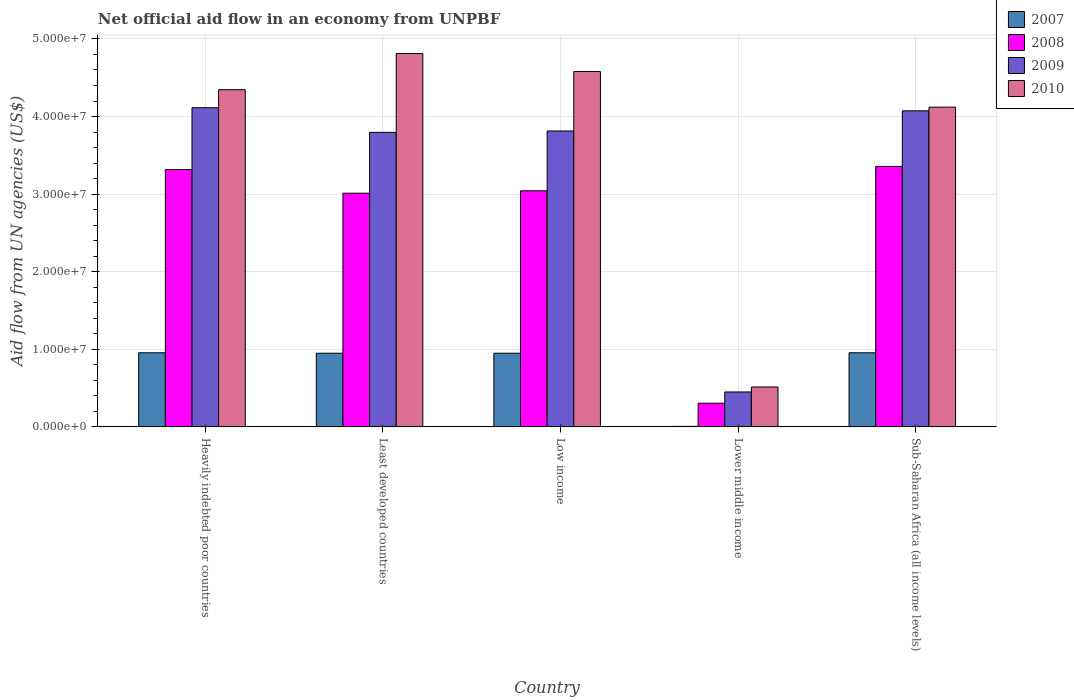How many different coloured bars are there?
Provide a short and direct response. 4. Are the number of bars per tick equal to the number of legend labels?
Your response must be concise. Yes. How many bars are there on the 4th tick from the left?
Your answer should be compact. 4. How many bars are there on the 1st tick from the right?
Your response must be concise. 4. What is the label of the 1st group of bars from the left?
Make the answer very short. Heavily indebted poor countries. In how many cases, is the number of bars for a given country not equal to the number of legend labels?
Keep it short and to the point. 0. What is the net official aid flow in 2007 in Low income?
Provide a succinct answer. 9.49e+06. Across all countries, what is the maximum net official aid flow in 2010?
Your response must be concise. 4.81e+07. Across all countries, what is the minimum net official aid flow in 2010?
Your response must be concise. 5.14e+06. In which country was the net official aid flow in 2010 maximum?
Your response must be concise. Least developed countries. In which country was the net official aid flow in 2010 minimum?
Your response must be concise. Lower middle income. What is the total net official aid flow in 2007 in the graph?
Provide a succinct answer. 3.81e+07. What is the difference between the net official aid flow in 2008 in Heavily indebted poor countries and the net official aid flow in 2009 in Low income?
Your answer should be compact. -4.97e+06. What is the average net official aid flow in 2010 per country?
Make the answer very short. 3.67e+07. What is the difference between the net official aid flow of/in 2008 and net official aid flow of/in 2007 in Least developed countries?
Offer a terse response. 2.06e+07. What is the ratio of the net official aid flow in 2010 in Heavily indebted poor countries to that in Least developed countries?
Ensure brevity in your answer.  0.9. Is the net official aid flow in 2009 in Least developed countries less than that in Low income?
Your answer should be very brief. Yes. What is the difference between the highest and the second highest net official aid flow in 2009?
Ensure brevity in your answer.  3.00e+06. What is the difference between the highest and the lowest net official aid flow in 2010?
Keep it short and to the point. 4.30e+07. Is the sum of the net official aid flow in 2007 in Heavily indebted poor countries and Lower middle income greater than the maximum net official aid flow in 2010 across all countries?
Provide a short and direct response. No. What does the 1st bar from the left in Low income represents?
Your answer should be compact. 2007. What does the 4th bar from the right in Least developed countries represents?
Offer a very short reply. 2007. Is it the case that in every country, the sum of the net official aid flow in 2007 and net official aid flow in 2009 is greater than the net official aid flow in 2010?
Your answer should be very brief. No. What is the difference between two consecutive major ticks on the Y-axis?
Make the answer very short. 1.00e+07. Are the values on the major ticks of Y-axis written in scientific E-notation?
Offer a terse response. Yes. Does the graph contain any zero values?
Provide a short and direct response. No. Does the graph contain grids?
Your answer should be compact. Yes. Where does the legend appear in the graph?
Your answer should be very brief. Top right. How many legend labels are there?
Offer a terse response. 4. What is the title of the graph?
Provide a succinct answer. Net official aid flow in an economy from UNPBF. What is the label or title of the Y-axis?
Your response must be concise. Aid flow from UN agencies (US$). What is the Aid flow from UN agencies (US$) in 2007 in Heavily indebted poor countries?
Provide a short and direct response. 9.55e+06. What is the Aid flow from UN agencies (US$) of 2008 in Heavily indebted poor countries?
Make the answer very short. 3.32e+07. What is the Aid flow from UN agencies (US$) of 2009 in Heavily indebted poor countries?
Keep it short and to the point. 4.11e+07. What is the Aid flow from UN agencies (US$) of 2010 in Heavily indebted poor countries?
Your response must be concise. 4.35e+07. What is the Aid flow from UN agencies (US$) of 2007 in Least developed countries?
Make the answer very short. 9.49e+06. What is the Aid flow from UN agencies (US$) in 2008 in Least developed countries?
Make the answer very short. 3.01e+07. What is the Aid flow from UN agencies (US$) in 2009 in Least developed countries?
Your answer should be very brief. 3.80e+07. What is the Aid flow from UN agencies (US$) in 2010 in Least developed countries?
Your response must be concise. 4.81e+07. What is the Aid flow from UN agencies (US$) in 2007 in Low income?
Keep it short and to the point. 9.49e+06. What is the Aid flow from UN agencies (US$) of 2008 in Low income?
Make the answer very short. 3.04e+07. What is the Aid flow from UN agencies (US$) of 2009 in Low income?
Offer a very short reply. 3.81e+07. What is the Aid flow from UN agencies (US$) of 2010 in Low income?
Keep it short and to the point. 4.58e+07. What is the Aid flow from UN agencies (US$) of 2008 in Lower middle income?
Your response must be concise. 3.05e+06. What is the Aid flow from UN agencies (US$) in 2009 in Lower middle income?
Give a very brief answer. 4.50e+06. What is the Aid flow from UN agencies (US$) of 2010 in Lower middle income?
Your response must be concise. 5.14e+06. What is the Aid flow from UN agencies (US$) in 2007 in Sub-Saharan Africa (all income levels)?
Make the answer very short. 9.55e+06. What is the Aid flow from UN agencies (US$) in 2008 in Sub-Saharan Africa (all income levels)?
Offer a terse response. 3.36e+07. What is the Aid flow from UN agencies (US$) of 2009 in Sub-Saharan Africa (all income levels)?
Your answer should be compact. 4.07e+07. What is the Aid flow from UN agencies (US$) in 2010 in Sub-Saharan Africa (all income levels)?
Provide a short and direct response. 4.12e+07. Across all countries, what is the maximum Aid flow from UN agencies (US$) of 2007?
Ensure brevity in your answer.  9.55e+06. Across all countries, what is the maximum Aid flow from UN agencies (US$) in 2008?
Give a very brief answer. 3.36e+07. Across all countries, what is the maximum Aid flow from UN agencies (US$) in 2009?
Your response must be concise. 4.11e+07. Across all countries, what is the maximum Aid flow from UN agencies (US$) in 2010?
Provide a succinct answer. 4.81e+07. Across all countries, what is the minimum Aid flow from UN agencies (US$) in 2007?
Keep it short and to the point. 6.00e+04. Across all countries, what is the minimum Aid flow from UN agencies (US$) of 2008?
Offer a very short reply. 3.05e+06. Across all countries, what is the minimum Aid flow from UN agencies (US$) in 2009?
Make the answer very short. 4.50e+06. Across all countries, what is the minimum Aid flow from UN agencies (US$) in 2010?
Give a very brief answer. 5.14e+06. What is the total Aid flow from UN agencies (US$) in 2007 in the graph?
Keep it short and to the point. 3.81e+07. What is the total Aid flow from UN agencies (US$) in 2008 in the graph?
Keep it short and to the point. 1.30e+08. What is the total Aid flow from UN agencies (US$) in 2009 in the graph?
Your answer should be very brief. 1.62e+08. What is the total Aid flow from UN agencies (US$) of 2010 in the graph?
Offer a very short reply. 1.84e+08. What is the difference between the Aid flow from UN agencies (US$) of 2007 in Heavily indebted poor countries and that in Least developed countries?
Provide a succinct answer. 6.00e+04. What is the difference between the Aid flow from UN agencies (US$) in 2008 in Heavily indebted poor countries and that in Least developed countries?
Offer a terse response. 3.05e+06. What is the difference between the Aid flow from UN agencies (US$) in 2009 in Heavily indebted poor countries and that in Least developed countries?
Provide a succinct answer. 3.18e+06. What is the difference between the Aid flow from UN agencies (US$) in 2010 in Heavily indebted poor countries and that in Least developed countries?
Make the answer very short. -4.66e+06. What is the difference between the Aid flow from UN agencies (US$) of 2008 in Heavily indebted poor countries and that in Low income?
Your answer should be compact. 2.74e+06. What is the difference between the Aid flow from UN agencies (US$) in 2010 in Heavily indebted poor countries and that in Low income?
Offer a terse response. -2.34e+06. What is the difference between the Aid flow from UN agencies (US$) in 2007 in Heavily indebted poor countries and that in Lower middle income?
Give a very brief answer. 9.49e+06. What is the difference between the Aid flow from UN agencies (US$) in 2008 in Heavily indebted poor countries and that in Lower middle income?
Your answer should be compact. 3.01e+07. What is the difference between the Aid flow from UN agencies (US$) of 2009 in Heavily indebted poor countries and that in Lower middle income?
Make the answer very short. 3.66e+07. What is the difference between the Aid flow from UN agencies (US$) of 2010 in Heavily indebted poor countries and that in Lower middle income?
Your response must be concise. 3.83e+07. What is the difference between the Aid flow from UN agencies (US$) in 2007 in Heavily indebted poor countries and that in Sub-Saharan Africa (all income levels)?
Your answer should be very brief. 0. What is the difference between the Aid flow from UN agencies (US$) in 2008 in Heavily indebted poor countries and that in Sub-Saharan Africa (all income levels)?
Give a very brief answer. -4.00e+05. What is the difference between the Aid flow from UN agencies (US$) of 2010 in Heavily indebted poor countries and that in Sub-Saharan Africa (all income levels)?
Make the answer very short. 2.25e+06. What is the difference between the Aid flow from UN agencies (US$) of 2007 in Least developed countries and that in Low income?
Provide a succinct answer. 0. What is the difference between the Aid flow from UN agencies (US$) of 2008 in Least developed countries and that in Low income?
Offer a very short reply. -3.10e+05. What is the difference between the Aid flow from UN agencies (US$) in 2010 in Least developed countries and that in Low income?
Make the answer very short. 2.32e+06. What is the difference between the Aid flow from UN agencies (US$) of 2007 in Least developed countries and that in Lower middle income?
Provide a succinct answer. 9.43e+06. What is the difference between the Aid flow from UN agencies (US$) in 2008 in Least developed countries and that in Lower middle income?
Your response must be concise. 2.71e+07. What is the difference between the Aid flow from UN agencies (US$) in 2009 in Least developed countries and that in Lower middle income?
Provide a succinct answer. 3.35e+07. What is the difference between the Aid flow from UN agencies (US$) of 2010 in Least developed countries and that in Lower middle income?
Make the answer very short. 4.30e+07. What is the difference between the Aid flow from UN agencies (US$) of 2007 in Least developed countries and that in Sub-Saharan Africa (all income levels)?
Give a very brief answer. -6.00e+04. What is the difference between the Aid flow from UN agencies (US$) of 2008 in Least developed countries and that in Sub-Saharan Africa (all income levels)?
Your answer should be very brief. -3.45e+06. What is the difference between the Aid flow from UN agencies (US$) of 2009 in Least developed countries and that in Sub-Saharan Africa (all income levels)?
Make the answer very short. -2.78e+06. What is the difference between the Aid flow from UN agencies (US$) of 2010 in Least developed countries and that in Sub-Saharan Africa (all income levels)?
Keep it short and to the point. 6.91e+06. What is the difference between the Aid flow from UN agencies (US$) in 2007 in Low income and that in Lower middle income?
Your response must be concise. 9.43e+06. What is the difference between the Aid flow from UN agencies (US$) of 2008 in Low income and that in Lower middle income?
Your answer should be compact. 2.74e+07. What is the difference between the Aid flow from UN agencies (US$) in 2009 in Low income and that in Lower middle income?
Offer a terse response. 3.36e+07. What is the difference between the Aid flow from UN agencies (US$) of 2010 in Low income and that in Lower middle income?
Give a very brief answer. 4.07e+07. What is the difference between the Aid flow from UN agencies (US$) of 2008 in Low income and that in Sub-Saharan Africa (all income levels)?
Your response must be concise. -3.14e+06. What is the difference between the Aid flow from UN agencies (US$) of 2009 in Low income and that in Sub-Saharan Africa (all income levels)?
Offer a terse response. -2.60e+06. What is the difference between the Aid flow from UN agencies (US$) of 2010 in Low income and that in Sub-Saharan Africa (all income levels)?
Make the answer very short. 4.59e+06. What is the difference between the Aid flow from UN agencies (US$) of 2007 in Lower middle income and that in Sub-Saharan Africa (all income levels)?
Your response must be concise. -9.49e+06. What is the difference between the Aid flow from UN agencies (US$) in 2008 in Lower middle income and that in Sub-Saharan Africa (all income levels)?
Give a very brief answer. -3.05e+07. What is the difference between the Aid flow from UN agencies (US$) of 2009 in Lower middle income and that in Sub-Saharan Africa (all income levels)?
Your answer should be compact. -3.62e+07. What is the difference between the Aid flow from UN agencies (US$) in 2010 in Lower middle income and that in Sub-Saharan Africa (all income levels)?
Ensure brevity in your answer.  -3.61e+07. What is the difference between the Aid flow from UN agencies (US$) in 2007 in Heavily indebted poor countries and the Aid flow from UN agencies (US$) in 2008 in Least developed countries?
Provide a succinct answer. -2.06e+07. What is the difference between the Aid flow from UN agencies (US$) of 2007 in Heavily indebted poor countries and the Aid flow from UN agencies (US$) of 2009 in Least developed countries?
Offer a terse response. -2.84e+07. What is the difference between the Aid flow from UN agencies (US$) of 2007 in Heavily indebted poor countries and the Aid flow from UN agencies (US$) of 2010 in Least developed countries?
Provide a succinct answer. -3.86e+07. What is the difference between the Aid flow from UN agencies (US$) in 2008 in Heavily indebted poor countries and the Aid flow from UN agencies (US$) in 2009 in Least developed countries?
Provide a succinct answer. -4.79e+06. What is the difference between the Aid flow from UN agencies (US$) of 2008 in Heavily indebted poor countries and the Aid flow from UN agencies (US$) of 2010 in Least developed countries?
Give a very brief answer. -1.50e+07. What is the difference between the Aid flow from UN agencies (US$) in 2009 in Heavily indebted poor countries and the Aid flow from UN agencies (US$) in 2010 in Least developed countries?
Provide a succinct answer. -6.98e+06. What is the difference between the Aid flow from UN agencies (US$) in 2007 in Heavily indebted poor countries and the Aid flow from UN agencies (US$) in 2008 in Low income?
Offer a terse response. -2.09e+07. What is the difference between the Aid flow from UN agencies (US$) in 2007 in Heavily indebted poor countries and the Aid flow from UN agencies (US$) in 2009 in Low income?
Keep it short and to the point. -2.86e+07. What is the difference between the Aid flow from UN agencies (US$) in 2007 in Heavily indebted poor countries and the Aid flow from UN agencies (US$) in 2010 in Low income?
Give a very brief answer. -3.62e+07. What is the difference between the Aid flow from UN agencies (US$) in 2008 in Heavily indebted poor countries and the Aid flow from UN agencies (US$) in 2009 in Low income?
Provide a short and direct response. -4.97e+06. What is the difference between the Aid flow from UN agencies (US$) in 2008 in Heavily indebted poor countries and the Aid flow from UN agencies (US$) in 2010 in Low income?
Provide a short and direct response. -1.26e+07. What is the difference between the Aid flow from UN agencies (US$) in 2009 in Heavily indebted poor countries and the Aid flow from UN agencies (US$) in 2010 in Low income?
Keep it short and to the point. -4.66e+06. What is the difference between the Aid flow from UN agencies (US$) of 2007 in Heavily indebted poor countries and the Aid flow from UN agencies (US$) of 2008 in Lower middle income?
Your answer should be compact. 6.50e+06. What is the difference between the Aid flow from UN agencies (US$) of 2007 in Heavily indebted poor countries and the Aid flow from UN agencies (US$) of 2009 in Lower middle income?
Provide a succinct answer. 5.05e+06. What is the difference between the Aid flow from UN agencies (US$) of 2007 in Heavily indebted poor countries and the Aid flow from UN agencies (US$) of 2010 in Lower middle income?
Your response must be concise. 4.41e+06. What is the difference between the Aid flow from UN agencies (US$) of 2008 in Heavily indebted poor countries and the Aid flow from UN agencies (US$) of 2009 in Lower middle income?
Keep it short and to the point. 2.87e+07. What is the difference between the Aid flow from UN agencies (US$) of 2008 in Heavily indebted poor countries and the Aid flow from UN agencies (US$) of 2010 in Lower middle income?
Provide a short and direct response. 2.80e+07. What is the difference between the Aid flow from UN agencies (US$) of 2009 in Heavily indebted poor countries and the Aid flow from UN agencies (US$) of 2010 in Lower middle income?
Keep it short and to the point. 3.60e+07. What is the difference between the Aid flow from UN agencies (US$) in 2007 in Heavily indebted poor countries and the Aid flow from UN agencies (US$) in 2008 in Sub-Saharan Africa (all income levels)?
Give a very brief answer. -2.40e+07. What is the difference between the Aid flow from UN agencies (US$) of 2007 in Heavily indebted poor countries and the Aid flow from UN agencies (US$) of 2009 in Sub-Saharan Africa (all income levels)?
Offer a terse response. -3.12e+07. What is the difference between the Aid flow from UN agencies (US$) in 2007 in Heavily indebted poor countries and the Aid flow from UN agencies (US$) in 2010 in Sub-Saharan Africa (all income levels)?
Offer a very short reply. -3.17e+07. What is the difference between the Aid flow from UN agencies (US$) in 2008 in Heavily indebted poor countries and the Aid flow from UN agencies (US$) in 2009 in Sub-Saharan Africa (all income levels)?
Provide a short and direct response. -7.57e+06. What is the difference between the Aid flow from UN agencies (US$) in 2008 in Heavily indebted poor countries and the Aid flow from UN agencies (US$) in 2010 in Sub-Saharan Africa (all income levels)?
Provide a short and direct response. -8.04e+06. What is the difference between the Aid flow from UN agencies (US$) of 2009 in Heavily indebted poor countries and the Aid flow from UN agencies (US$) of 2010 in Sub-Saharan Africa (all income levels)?
Provide a short and direct response. -7.00e+04. What is the difference between the Aid flow from UN agencies (US$) in 2007 in Least developed countries and the Aid flow from UN agencies (US$) in 2008 in Low income?
Your response must be concise. -2.09e+07. What is the difference between the Aid flow from UN agencies (US$) in 2007 in Least developed countries and the Aid flow from UN agencies (US$) in 2009 in Low income?
Offer a terse response. -2.86e+07. What is the difference between the Aid flow from UN agencies (US$) in 2007 in Least developed countries and the Aid flow from UN agencies (US$) in 2010 in Low income?
Keep it short and to the point. -3.63e+07. What is the difference between the Aid flow from UN agencies (US$) of 2008 in Least developed countries and the Aid flow from UN agencies (US$) of 2009 in Low income?
Offer a very short reply. -8.02e+06. What is the difference between the Aid flow from UN agencies (US$) of 2008 in Least developed countries and the Aid flow from UN agencies (US$) of 2010 in Low income?
Ensure brevity in your answer.  -1.57e+07. What is the difference between the Aid flow from UN agencies (US$) in 2009 in Least developed countries and the Aid flow from UN agencies (US$) in 2010 in Low income?
Your response must be concise. -7.84e+06. What is the difference between the Aid flow from UN agencies (US$) in 2007 in Least developed countries and the Aid flow from UN agencies (US$) in 2008 in Lower middle income?
Give a very brief answer. 6.44e+06. What is the difference between the Aid flow from UN agencies (US$) in 2007 in Least developed countries and the Aid flow from UN agencies (US$) in 2009 in Lower middle income?
Your answer should be very brief. 4.99e+06. What is the difference between the Aid flow from UN agencies (US$) of 2007 in Least developed countries and the Aid flow from UN agencies (US$) of 2010 in Lower middle income?
Offer a very short reply. 4.35e+06. What is the difference between the Aid flow from UN agencies (US$) in 2008 in Least developed countries and the Aid flow from UN agencies (US$) in 2009 in Lower middle income?
Your answer should be compact. 2.56e+07. What is the difference between the Aid flow from UN agencies (US$) of 2008 in Least developed countries and the Aid flow from UN agencies (US$) of 2010 in Lower middle income?
Ensure brevity in your answer.  2.50e+07. What is the difference between the Aid flow from UN agencies (US$) in 2009 in Least developed countries and the Aid flow from UN agencies (US$) in 2010 in Lower middle income?
Make the answer very short. 3.28e+07. What is the difference between the Aid flow from UN agencies (US$) of 2007 in Least developed countries and the Aid flow from UN agencies (US$) of 2008 in Sub-Saharan Africa (all income levels)?
Offer a terse response. -2.41e+07. What is the difference between the Aid flow from UN agencies (US$) in 2007 in Least developed countries and the Aid flow from UN agencies (US$) in 2009 in Sub-Saharan Africa (all income levels)?
Your answer should be very brief. -3.12e+07. What is the difference between the Aid flow from UN agencies (US$) of 2007 in Least developed countries and the Aid flow from UN agencies (US$) of 2010 in Sub-Saharan Africa (all income levels)?
Keep it short and to the point. -3.17e+07. What is the difference between the Aid flow from UN agencies (US$) of 2008 in Least developed countries and the Aid flow from UN agencies (US$) of 2009 in Sub-Saharan Africa (all income levels)?
Provide a short and direct response. -1.06e+07. What is the difference between the Aid flow from UN agencies (US$) in 2008 in Least developed countries and the Aid flow from UN agencies (US$) in 2010 in Sub-Saharan Africa (all income levels)?
Give a very brief answer. -1.11e+07. What is the difference between the Aid flow from UN agencies (US$) in 2009 in Least developed countries and the Aid flow from UN agencies (US$) in 2010 in Sub-Saharan Africa (all income levels)?
Offer a very short reply. -3.25e+06. What is the difference between the Aid flow from UN agencies (US$) in 2007 in Low income and the Aid flow from UN agencies (US$) in 2008 in Lower middle income?
Keep it short and to the point. 6.44e+06. What is the difference between the Aid flow from UN agencies (US$) in 2007 in Low income and the Aid flow from UN agencies (US$) in 2009 in Lower middle income?
Ensure brevity in your answer.  4.99e+06. What is the difference between the Aid flow from UN agencies (US$) of 2007 in Low income and the Aid flow from UN agencies (US$) of 2010 in Lower middle income?
Give a very brief answer. 4.35e+06. What is the difference between the Aid flow from UN agencies (US$) in 2008 in Low income and the Aid flow from UN agencies (US$) in 2009 in Lower middle income?
Provide a succinct answer. 2.59e+07. What is the difference between the Aid flow from UN agencies (US$) in 2008 in Low income and the Aid flow from UN agencies (US$) in 2010 in Lower middle income?
Your response must be concise. 2.53e+07. What is the difference between the Aid flow from UN agencies (US$) of 2009 in Low income and the Aid flow from UN agencies (US$) of 2010 in Lower middle income?
Provide a short and direct response. 3.30e+07. What is the difference between the Aid flow from UN agencies (US$) of 2007 in Low income and the Aid flow from UN agencies (US$) of 2008 in Sub-Saharan Africa (all income levels)?
Provide a succinct answer. -2.41e+07. What is the difference between the Aid flow from UN agencies (US$) in 2007 in Low income and the Aid flow from UN agencies (US$) in 2009 in Sub-Saharan Africa (all income levels)?
Provide a short and direct response. -3.12e+07. What is the difference between the Aid flow from UN agencies (US$) of 2007 in Low income and the Aid flow from UN agencies (US$) of 2010 in Sub-Saharan Africa (all income levels)?
Offer a terse response. -3.17e+07. What is the difference between the Aid flow from UN agencies (US$) of 2008 in Low income and the Aid flow from UN agencies (US$) of 2009 in Sub-Saharan Africa (all income levels)?
Provide a short and direct response. -1.03e+07. What is the difference between the Aid flow from UN agencies (US$) in 2008 in Low income and the Aid flow from UN agencies (US$) in 2010 in Sub-Saharan Africa (all income levels)?
Provide a succinct answer. -1.08e+07. What is the difference between the Aid flow from UN agencies (US$) of 2009 in Low income and the Aid flow from UN agencies (US$) of 2010 in Sub-Saharan Africa (all income levels)?
Make the answer very short. -3.07e+06. What is the difference between the Aid flow from UN agencies (US$) in 2007 in Lower middle income and the Aid flow from UN agencies (US$) in 2008 in Sub-Saharan Africa (all income levels)?
Your answer should be very brief. -3.35e+07. What is the difference between the Aid flow from UN agencies (US$) of 2007 in Lower middle income and the Aid flow from UN agencies (US$) of 2009 in Sub-Saharan Africa (all income levels)?
Your response must be concise. -4.07e+07. What is the difference between the Aid flow from UN agencies (US$) in 2007 in Lower middle income and the Aid flow from UN agencies (US$) in 2010 in Sub-Saharan Africa (all income levels)?
Keep it short and to the point. -4.12e+07. What is the difference between the Aid flow from UN agencies (US$) in 2008 in Lower middle income and the Aid flow from UN agencies (US$) in 2009 in Sub-Saharan Africa (all income levels)?
Keep it short and to the point. -3.77e+07. What is the difference between the Aid flow from UN agencies (US$) of 2008 in Lower middle income and the Aid flow from UN agencies (US$) of 2010 in Sub-Saharan Africa (all income levels)?
Your answer should be compact. -3.82e+07. What is the difference between the Aid flow from UN agencies (US$) of 2009 in Lower middle income and the Aid flow from UN agencies (US$) of 2010 in Sub-Saharan Africa (all income levels)?
Offer a very short reply. -3.67e+07. What is the average Aid flow from UN agencies (US$) in 2007 per country?
Keep it short and to the point. 7.63e+06. What is the average Aid flow from UN agencies (US$) in 2008 per country?
Your answer should be compact. 2.61e+07. What is the average Aid flow from UN agencies (US$) of 2009 per country?
Offer a terse response. 3.25e+07. What is the average Aid flow from UN agencies (US$) in 2010 per country?
Keep it short and to the point. 3.67e+07. What is the difference between the Aid flow from UN agencies (US$) of 2007 and Aid flow from UN agencies (US$) of 2008 in Heavily indebted poor countries?
Provide a short and direct response. -2.36e+07. What is the difference between the Aid flow from UN agencies (US$) of 2007 and Aid flow from UN agencies (US$) of 2009 in Heavily indebted poor countries?
Give a very brief answer. -3.16e+07. What is the difference between the Aid flow from UN agencies (US$) in 2007 and Aid flow from UN agencies (US$) in 2010 in Heavily indebted poor countries?
Provide a short and direct response. -3.39e+07. What is the difference between the Aid flow from UN agencies (US$) in 2008 and Aid flow from UN agencies (US$) in 2009 in Heavily indebted poor countries?
Your answer should be compact. -7.97e+06. What is the difference between the Aid flow from UN agencies (US$) in 2008 and Aid flow from UN agencies (US$) in 2010 in Heavily indebted poor countries?
Give a very brief answer. -1.03e+07. What is the difference between the Aid flow from UN agencies (US$) of 2009 and Aid flow from UN agencies (US$) of 2010 in Heavily indebted poor countries?
Make the answer very short. -2.32e+06. What is the difference between the Aid flow from UN agencies (US$) of 2007 and Aid flow from UN agencies (US$) of 2008 in Least developed countries?
Provide a short and direct response. -2.06e+07. What is the difference between the Aid flow from UN agencies (US$) of 2007 and Aid flow from UN agencies (US$) of 2009 in Least developed countries?
Make the answer very short. -2.85e+07. What is the difference between the Aid flow from UN agencies (US$) in 2007 and Aid flow from UN agencies (US$) in 2010 in Least developed countries?
Provide a short and direct response. -3.86e+07. What is the difference between the Aid flow from UN agencies (US$) in 2008 and Aid flow from UN agencies (US$) in 2009 in Least developed countries?
Your answer should be very brief. -7.84e+06. What is the difference between the Aid flow from UN agencies (US$) of 2008 and Aid flow from UN agencies (US$) of 2010 in Least developed countries?
Provide a succinct answer. -1.80e+07. What is the difference between the Aid flow from UN agencies (US$) of 2009 and Aid flow from UN agencies (US$) of 2010 in Least developed countries?
Your answer should be compact. -1.02e+07. What is the difference between the Aid flow from UN agencies (US$) in 2007 and Aid flow from UN agencies (US$) in 2008 in Low income?
Your answer should be very brief. -2.09e+07. What is the difference between the Aid flow from UN agencies (US$) in 2007 and Aid flow from UN agencies (US$) in 2009 in Low income?
Offer a terse response. -2.86e+07. What is the difference between the Aid flow from UN agencies (US$) in 2007 and Aid flow from UN agencies (US$) in 2010 in Low income?
Provide a short and direct response. -3.63e+07. What is the difference between the Aid flow from UN agencies (US$) of 2008 and Aid flow from UN agencies (US$) of 2009 in Low income?
Your answer should be very brief. -7.71e+06. What is the difference between the Aid flow from UN agencies (US$) of 2008 and Aid flow from UN agencies (US$) of 2010 in Low income?
Make the answer very short. -1.54e+07. What is the difference between the Aid flow from UN agencies (US$) of 2009 and Aid flow from UN agencies (US$) of 2010 in Low income?
Provide a succinct answer. -7.66e+06. What is the difference between the Aid flow from UN agencies (US$) of 2007 and Aid flow from UN agencies (US$) of 2008 in Lower middle income?
Provide a succinct answer. -2.99e+06. What is the difference between the Aid flow from UN agencies (US$) of 2007 and Aid flow from UN agencies (US$) of 2009 in Lower middle income?
Offer a very short reply. -4.44e+06. What is the difference between the Aid flow from UN agencies (US$) of 2007 and Aid flow from UN agencies (US$) of 2010 in Lower middle income?
Your answer should be compact. -5.08e+06. What is the difference between the Aid flow from UN agencies (US$) of 2008 and Aid flow from UN agencies (US$) of 2009 in Lower middle income?
Keep it short and to the point. -1.45e+06. What is the difference between the Aid flow from UN agencies (US$) of 2008 and Aid flow from UN agencies (US$) of 2010 in Lower middle income?
Your answer should be very brief. -2.09e+06. What is the difference between the Aid flow from UN agencies (US$) in 2009 and Aid flow from UN agencies (US$) in 2010 in Lower middle income?
Give a very brief answer. -6.40e+05. What is the difference between the Aid flow from UN agencies (US$) in 2007 and Aid flow from UN agencies (US$) in 2008 in Sub-Saharan Africa (all income levels)?
Your response must be concise. -2.40e+07. What is the difference between the Aid flow from UN agencies (US$) of 2007 and Aid flow from UN agencies (US$) of 2009 in Sub-Saharan Africa (all income levels)?
Your answer should be very brief. -3.12e+07. What is the difference between the Aid flow from UN agencies (US$) in 2007 and Aid flow from UN agencies (US$) in 2010 in Sub-Saharan Africa (all income levels)?
Make the answer very short. -3.17e+07. What is the difference between the Aid flow from UN agencies (US$) in 2008 and Aid flow from UN agencies (US$) in 2009 in Sub-Saharan Africa (all income levels)?
Provide a succinct answer. -7.17e+06. What is the difference between the Aid flow from UN agencies (US$) of 2008 and Aid flow from UN agencies (US$) of 2010 in Sub-Saharan Africa (all income levels)?
Your answer should be very brief. -7.64e+06. What is the difference between the Aid flow from UN agencies (US$) in 2009 and Aid flow from UN agencies (US$) in 2010 in Sub-Saharan Africa (all income levels)?
Ensure brevity in your answer.  -4.70e+05. What is the ratio of the Aid flow from UN agencies (US$) of 2007 in Heavily indebted poor countries to that in Least developed countries?
Provide a short and direct response. 1.01. What is the ratio of the Aid flow from UN agencies (US$) in 2008 in Heavily indebted poor countries to that in Least developed countries?
Make the answer very short. 1.1. What is the ratio of the Aid flow from UN agencies (US$) of 2009 in Heavily indebted poor countries to that in Least developed countries?
Provide a succinct answer. 1.08. What is the ratio of the Aid flow from UN agencies (US$) in 2010 in Heavily indebted poor countries to that in Least developed countries?
Offer a terse response. 0.9. What is the ratio of the Aid flow from UN agencies (US$) in 2008 in Heavily indebted poor countries to that in Low income?
Keep it short and to the point. 1.09. What is the ratio of the Aid flow from UN agencies (US$) of 2009 in Heavily indebted poor countries to that in Low income?
Your response must be concise. 1.08. What is the ratio of the Aid flow from UN agencies (US$) of 2010 in Heavily indebted poor countries to that in Low income?
Provide a succinct answer. 0.95. What is the ratio of the Aid flow from UN agencies (US$) in 2007 in Heavily indebted poor countries to that in Lower middle income?
Your response must be concise. 159.17. What is the ratio of the Aid flow from UN agencies (US$) of 2008 in Heavily indebted poor countries to that in Lower middle income?
Provide a short and direct response. 10.88. What is the ratio of the Aid flow from UN agencies (US$) in 2009 in Heavily indebted poor countries to that in Lower middle income?
Give a very brief answer. 9.14. What is the ratio of the Aid flow from UN agencies (US$) of 2010 in Heavily indebted poor countries to that in Lower middle income?
Give a very brief answer. 8.46. What is the ratio of the Aid flow from UN agencies (US$) of 2007 in Heavily indebted poor countries to that in Sub-Saharan Africa (all income levels)?
Offer a terse response. 1. What is the ratio of the Aid flow from UN agencies (US$) of 2008 in Heavily indebted poor countries to that in Sub-Saharan Africa (all income levels)?
Offer a very short reply. 0.99. What is the ratio of the Aid flow from UN agencies (US$) in 2009 in Heavily indebted poor countries to that in Sub-Saharan Africa (all income levels)?
Your answer should be compact. 1.01. What is the ratio of the Aid flow from UN agencies (US$) of 2010 in Heavily indebted poor countries to that in Sub-Saharan Africa (all income levels)?
Your answer should be compact. 1.05. What is the ratio of the Aid flow from UN agencies (US$) of 2007 in Least developed countries to that in Low income?
Make the answer very short. 1. What is the ratio of the Aid flow from UN agencies (US$) in 2010 in Least developed countries to that in Low income?
Ensure brevity in your answer.  1.05. What is the ratio of the Aid flow from UN agencies (US$) in 2007 in Least developed countries to that in Lower middle income?
Your response must be concise. 158.17. What is the ratio of the Aid flow from UN agencies (US$) of 2008 in Least developed countries to that in Lower middle income?
Give a very brief answer. 9.88. What is the ratio of the Aid flow from UN agencies (US$) of 2009 in Least developed countries to that in Lower middle income?
Your response must be concise. 8.44. What is the ratio of the Aid flow from UN agencies (US$) of 2010 in Least developed countries to that in Lower middle income?
Keep it short and to the point. 9.36. What is the ratio of the Aid flow from UN agencies (US$) in 2007 in Least developed countries to that in Sub-Saharan Africa (all income levels)?
Provide a short and direct response. 0.99. What is the ratio of the Aid flow from UN agencies (US$) of 2008 in Least developed countries to that in Sub-Saharan Africa (all income levels)?
Your response must be concise. 0.9. What is the ratio of the Aid flow from UN agencies (US$) of 2009 in Least developed countries to that in Sub-Saharan Africa (all income levels)?
Provide a short and direct response. 0.93. What is the ratio of the Aid flow from UN agencies (US$) in 2010 in Least developed countries to that in Sub-Saharan Africa (all income levels)?
Make the answer very short. 1.17. What is the ratio of the Aid flow from UN agencies (US$) in 2007 in Low income to that in Lower middle income?
Your answer should be compact. 158.17. What is the ratio of the Aid flow from UN agencies (US$) in 2008 in Low income to that in Lower middle income?
Provide a succinct answer. 9.98. What is the ratio of the Aid flow from UN agencies (US$) of 2009 in Low income to that in Lower middle income?
Your answer should be compact. 8.48. What is the ratio of the Aid flow from UN agencies (US$) in 2010 in Low income to that in Lower middle income?
Your answer should be very brief. 8.91. What is the ratio of the Aid flow from UN agencies (US$) of 2007 in Low income to that in Sub-Saharan Africa (all income levels)?
Offer a very short reply. 0.99. What is the ratio of the Aid flow from UN agencies (US$) in 2008 in Low income to that in Sub-Saharan Africa (all income levels)?
Give a very brief answer. 0.91. What is the ratio of the Aid flow from UN agencies (US$) in 2009 in Low income to that in Sub-Saharan Africa (all income levels)?
Your answer should be very brief. 0.94. What is the ratio of the Aid flow from UN agencies (US$) of 2010 in Low income to that in Sub-Saharan Africa (all income levels)?
Your answer should be compact. 1.11. What is the ratio of the Aid flow from UN agencies (US$) in 2007 in Lower middle income to that in Sub-Saharan Africa (all income levels)?
Provide a short and direct response. 0.01. What is the ratio of the Aid flow from UN agencies (US$) in 2008 in Lower middle income to that in Sub-Saharan Africa (all income levels)?
Offer a very short reply. 0.09. What is the ratio of the Aid flow from UN agencies (US$) in 2009 in Lower middle income to that in Sub-Saharan Africa (all income levels)?
Your answer should be compact. 0.11. What is the ratio of the Aid flow from UN agencies (US$) of 2010 in Lower middle income to that in Sub-Saharan Africa (all income levels)?
Your response must be concise. 0.12. What is the difference between the highest and the second highest Aid flow from UN agencies (US$) in 2008?
Your answer should be compact. 4.00e+05. What is the difference between the highest and the second highest Aid flow from UN agencies (US$) in 2009?
Offer a very short reply. 4.00e+05. What is the difference between the highest and the second highest Aid flow from UN agencies (US$) of 2010?
Offer a very short reply. 2.32e+06. What is the difference between the highest and the lowest Aid flow from UN agencies (US$) of 2007?
Offer a terse response. 9.49e+06. What is the difference between the highest and the lowest Aid flow from UN agencies (US$) in 2008?
Make the answer very short. 3.05e+07. What is the difference between the highest and the lowest Aid flow from UN agencies (US$) in 2009?
Ensure brevity in your answer.  3.66e+07. What is the difference between the highest and the lowest Aid flow from UN agencies (US$) in 2010?
Offer a very short reply. 4.30e+07. 